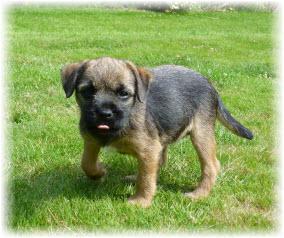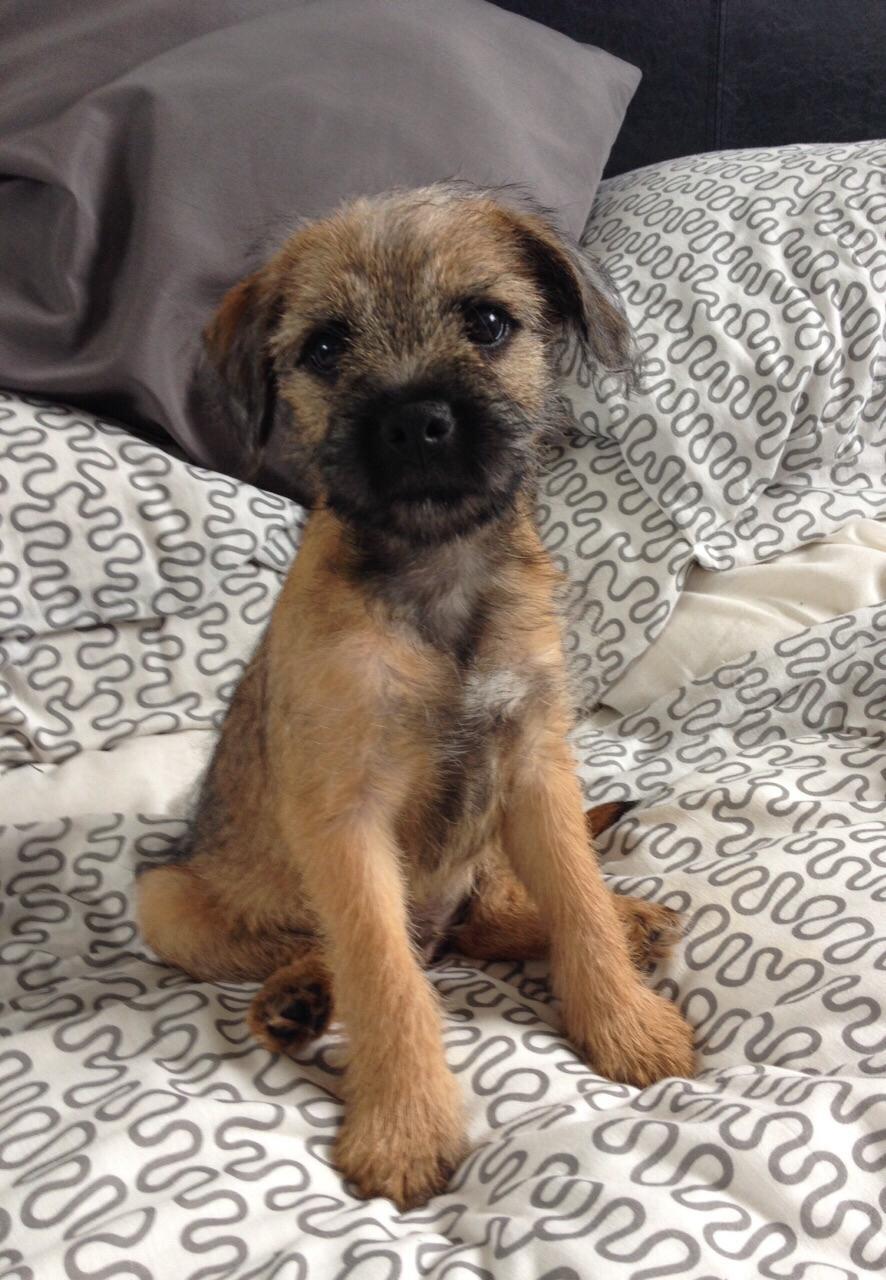The first image is the image on the left, the second image is the image on the right. For the images shown, is this caption "A dog is standing in the grass with the paw on the left raised." true? Answer yes or no. Yes. The first image is the image on the left, the second image is the image on the right. Assess this claim about the two images: "At least one dog is standing on grass.". Correct or not? Answer yes or no. Yes. The first image is the image on the left, the second image is the image on the right. For the images displayed, is the sentence "At least one image shows a small dog standing on green grass." factually correct? Answer yes or no. Yes. 